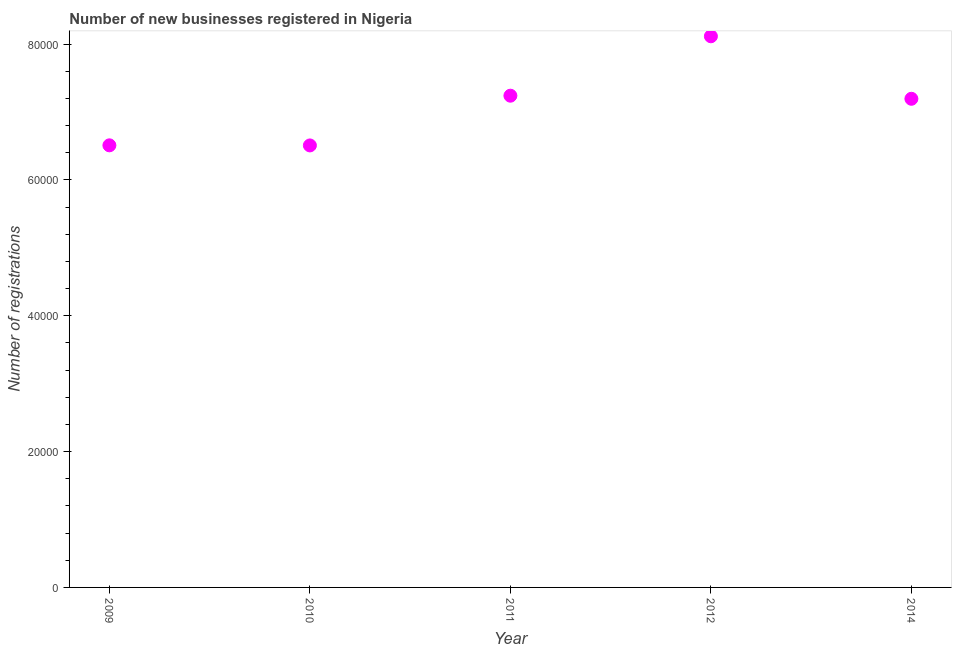What is the number of new business registrations in 2011?
Offer a terse response. 7.24e+04. Across all years, what is the maximum number of new business registrations?
Your answer should be compact. 8.11e+04. Across all years, what is the minimum number of new business registrations?
Provide a short and direct response. 6.51e+04. In which year was the number of new business registrations minimum?
Offer a very short reply. 2010. What is the sum of the number of new business registrations?
Keep it short and to the point. 3.56e+05. What is the difference between the number of new business registrations in 2012 and 2014?
Your response must be concise. 9203. What is the average number of new business registrations per year?
Provide a succinct answer. 7.11e+04. What is the median number of new business registrations?
Provide a succinct answer. 7.19e+04. In how many years, is the number of new business registrations greater than 64000 ?
Your response must be concise. 5. Do a majority of the years between 2011 and 2010 (inclusive) have number of new business registrations greater than 56000 ?
Ensure brevity in your answer.  No. What is the ratio of the number of new business registrations in 2009 to that in 2012?
Your answer should be compact. 0.8. Is the difference between the number of new business registrations in 2011 and 2014 greater than the difference between any two years?
Offer a terse response. No. What is the difference between the highest and the second highest number of new business registrations?
Make the answer very short. 8748. Is the sum of the number of new business registrations in 2010 and 2014 greater than the maximum number of new business registrations across all years?
Make the answer very short. Yes. What is the difference between the highest and the lowest number of new business registrations?
Provide a short and direct response. 1.61e+04. Does the number of new business registrations monotonically increase over the years?
Provide a succinct answer. No. Are the values on the major ticks of Y-axis written in scientific E-notation?
Your answer should be very brief. No. Does the graph contain any zero values?
Offer a very short reply. No. What is the title of the graph?
Keep it short and to the point. Number of new businesses registered in Nigeria. What is the label or title of the X-axis?
Your answer should be very brief. Year. What is the label or title of the Y-axis?
Give a very brief answer. Number of registrations. What is the Number of registrations in 2009?
Make the answer very short. 6.51e+04. What is the Number of registrations in 2010?
Ensure brevity in your answer.  6.51e+04. What is the Number of registrations in 2011?
Give a very brief answer. 7.24e+04. What is the Number of registrations in 2012?
Make the answer very short. 8.11e+04. What is the Number of registrations in 2014?
Keep it short and to the point. 7.19e+04. What is the difference between the Number of registrations in 2009 and 2011?
Keep it short and to the point. -7307. What is the difference between the Number of registrations in 2009 and 2012?
Offer a terse response. -1.61e+04. What is the difference between the Number of registrations in 2009 and 2014?
Your answer should be very brief. -6852. What is the difference between the Number of registrations in 2010 and 2011?
Make the answer very short. -7322. What is the difference between the Number of registrations in 2010 and 2012?
Keep it short and to the point. -1.61e+04. What is the difference between the Number of registrations in 2010 and 2014?
Your response must be concise. -6867. What is the difference between the Number of registrations in 2011 and 2012?
Keep it short and to the point. -8748. What is the difference between the Number of registrations in 2011 and 2014?
Your answer should be very brief. 455. What is the difference between the Number of registrations in 2012 and 2014?
Keep it short and to the point. 9203. What is the ratio of the Number of registrations in 2009 to that in 2010?
Offer a very short reply. 1. What is the ratio of the Number of registrations in 2009 to that in 2011?
Make the answer very short. 0.9. What is the ratio of the Number of registrations in 2009 to that in 2012?
Provide a short and direct response. 0.8. What is the ratio of the Number of registrations in 2009 to that in 2014?
Ensure brevity in your answer.  0.91. What is the ratio of the Number of registrations in 2010 to that in 2011?
Make the answer very short. 0.9. What is the ratio of the Number of registrations in 2010 to that in 2012?
Your answer should be very brief. 0.8. What is the ratio of the Number of registrations in 2010 to that in 2014?
Offer a terse response. 0.91. What is the ratio of the Number of registrations in 2011 to that in 2012?
Give a very brief answer. 0.89. What is the ratio of the Number of registrations in 2011 to that in 2014?
Offer a terse response. 1.01. What is the ratio of the Number of registrations in 2012 to that in 2014?
Your response must be concise. 1.13. 